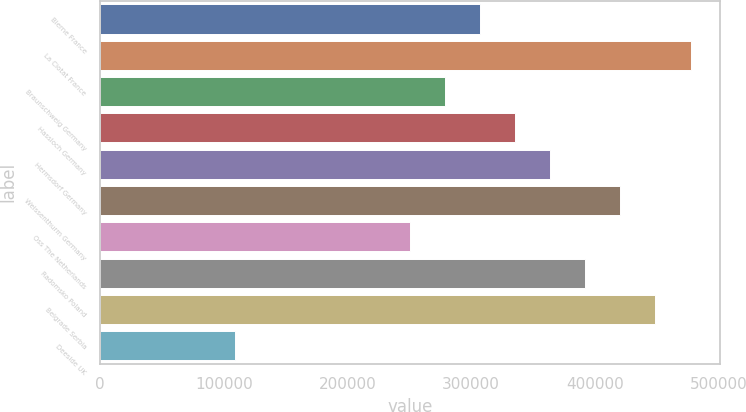<chart> <loc_0><loc_0><loc_500><loc_500><bar_chart><fcel>Bierne France<fcel>La Ciotat France<fcel>Braunschweig Germany<fcel>Hassloch Germany<fcel>Hermsdorf Germany<fcel>Weissenthurm Germany<fcel>Oss The Netherlands<fcel>Radomsko Poland<fcel>Belgrade Serbia<fcel>Deeside UK<nl><fcel>307200<fcel>477600<fcel>278800<fcel>335600<fcel>364000<fcel>420800<fcel>250400<fcel>392400<fcel>449200<fcel>109000<nl></chart> 